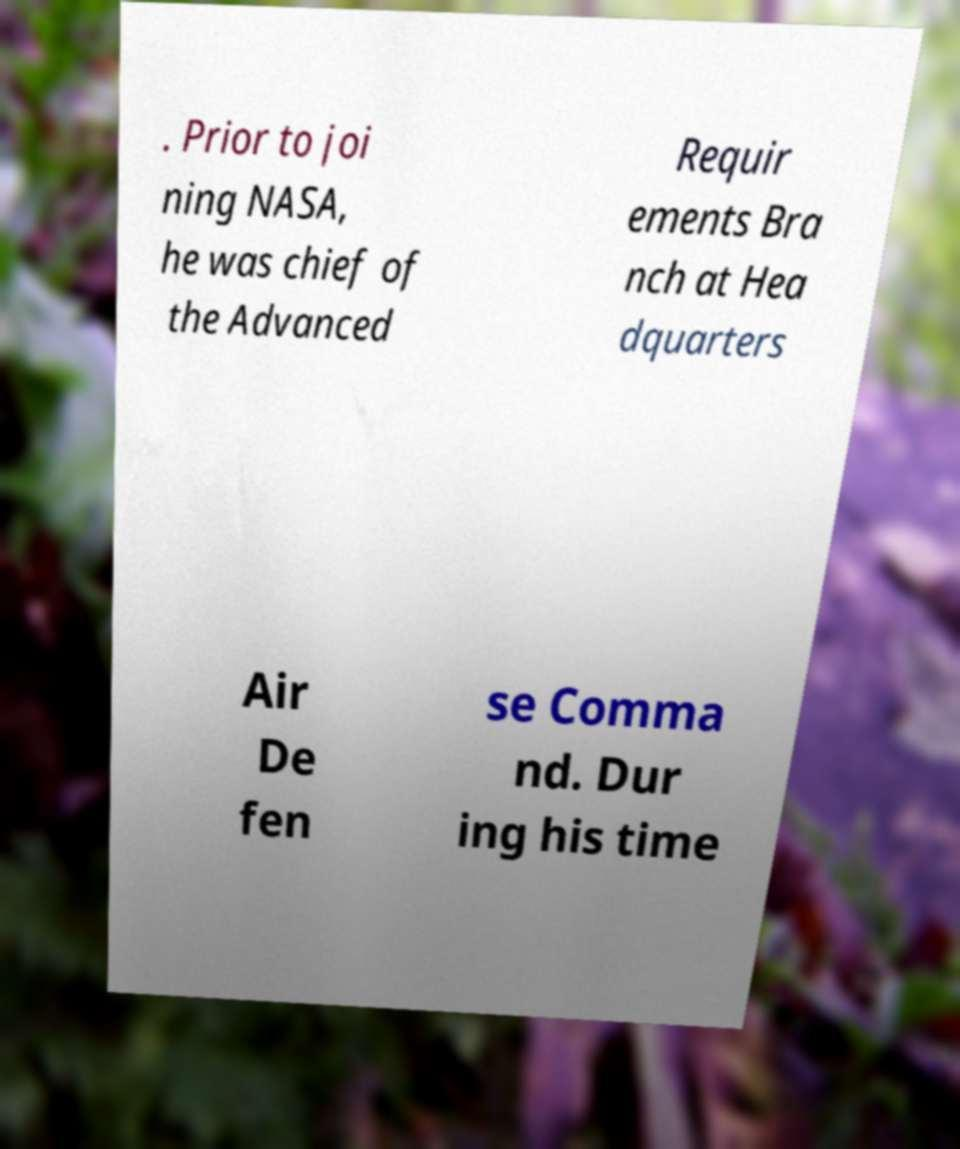Can you accurately transcribe the text from the provided image for me? . Prior to joi ning NASA, he was chief of the Advanced Requir ements Bra nch at Hea dquarters Air De fen se Comma nd. Dur ing his time 